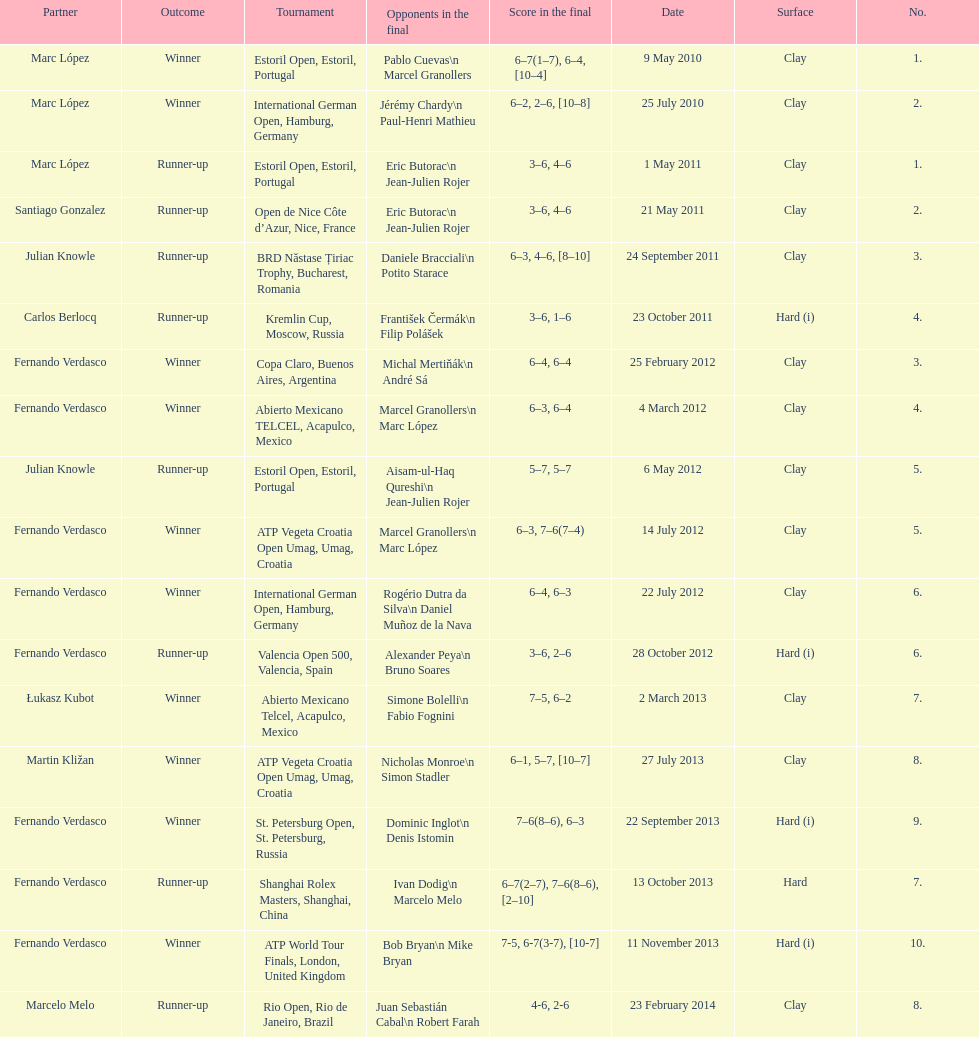How many tournaments has this player won in his career so far? 10. 